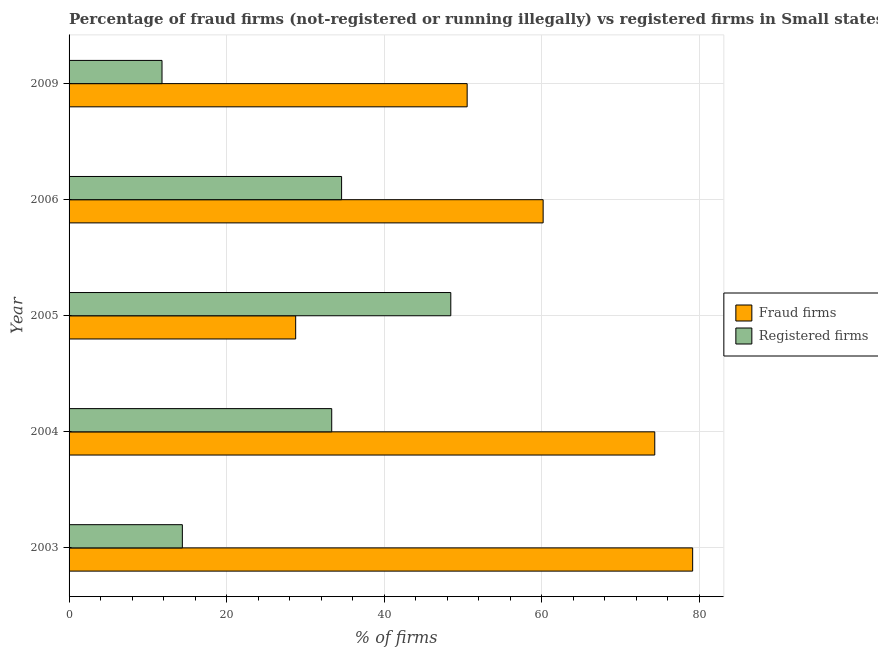How many different coloured bars are there?
Provide a succinct answer. 2. How many groups of bars are there?
Make the answer very short. 5. Are the number of bars per tick equal to the number of legend labels?
Your answer should be very brief. Yes. How many bars are there on the 2nd tick from the bottom?
Ensure brevity in your answer.  2. What is the percentage of fraud firms in 2004?
Offer a very short reply. 74.36. Across all years, what is the maximum percentage of registered firms?
Ensure brevity in your answer.  48.46. Across all years, what is the minimum percentage of fraud firms?
Provide a succinct answer. 28.77. What is the total percentage of registered firms in the graph?
Your answer should be very brief. 142.59. What is the difference between the percentage of fraud firms in 2003 and that in 2006?
Ensure brevity in your answer.  18.98. What is the difference between the percentage of fraud firms in 2006 and the percentage of registered firms in 2004?
Provide a short and direct response. 26.84. What is the average percentage of fraud firms per year?
Ensure brevity in your answer.  58.6. In the year 2005, what is the difference between the percentage of registered firms and percentage of fraud firms?
Provide a succinct answer. 19.69. What is the ratio of the percentage of registered firms in 2005 to that in 2009?
Ensure brevity in your answer.  4.11. Is the percentage of fraud firms in 2005 less than that in 2006?
Your answer should be compact. Yes. Is the difference between the percentage of fraud firms in 2004 and 2009 greater than the difference between the percentage of registered firms in 2004 and 2009?
Offer a terse response. Yes. What is the difference between the highest and the second highest percentage of registered firms?
Make the answer very short. 13.86. What is the difference between the highest and the lowest percentage of registered firms?
Ensure brevity in your answer.  36.66. In how many years, is the percentage of registered firms greater than the average percentage of registered firms taken over all years?
Your answer should be very brief. 3. What does the 1st bar from the top in 2005 represents?
Your response must be concise. Registered firms. What does the 2nd bar from the bottom in 2009 represents?
Your answer should be very brief. Registered firms. How many years are there in the graph?
Give a very brief answer. 5. What is the difference between two consecutive major ticks on the X-axis?
Provide a succinct answer. 20. Are the values on the major ticks of X-axis written in scientific E-notation?
Provide a short and direct response. No. Does the graph contain grids?
Your response must be concise. Yes. Where does the legend appear in the graph?
Your response must be concise. Center right. How are the legend labels stacked?
Keep it short and to the point. Vertical. What is the title of the graph?
Make the answer very short. Percentage of fraud firms (not-registered or running illegally) vs registered firms in Small states. Does "Primary income" appear as one of the legend labels in the graph?
Your answer should be very brief. No. What is the label or title of the X-axis?
Provide a short and direct response. % of firms. What is the label or title of the Y-axis?
Provide a short and direct response. Year. What is the % of firms of Fraud firms in 2003?
Offer a very short reply. 79.17. What is the % of firms in Registered firms in 2003?
Ensure brevity in your answer.  14.38. What is the % of firms of Fraud firms in 2004?
Give a very brief answer. 74.36. What is the % of firms in Registered firms in 2004?
Provide a succinct answer. 33.35. What is the % of firms of Fraud firms in 2005?
Ensure brevity in your answer.  28.77. What is the % of firms of Registered firms in 2005?
Keep it short and to the point. 48.46. What is the % of firms in Fraud firms in 2006?
Offer a terse response. 60.19. What is the % of firms in Registered firms in 2006?
Provide a succinct answer. 34.6. What is the % of firms in Fraud firms in 2009?
Keep it short and to the point. 50.54. What is the % of firms in Registered firms in 2009?
Give a very brief answer. 11.8. Across all years, what is the maximum % of firms of Fraud firms?
Offer a terse response. 79.17. Across all years, what is the maximum % of firms of Registered firms?
Offer a very short reply. 48.46. Across all years, what is the minimum % of firms in Fraud firms?
Your answer should be very brief. 28.77. Across all years, what is the minimum % of firms of Registered firms?
Your answer should be very brief. 11.8. What is the total % of firms in Fraud firms in the graph?
Provide a short and direct response. 293.03. What is the total % of firms of Registered firms in the graph?
Give a very brief answer. 142.59. What is the difference between the % of firms in Fraud firms in 2003 and that in 2004?
Provide a short and direct response. 4.81. What is the difference between the % of firms in Registered firms in 2003 and that in 2004?
Your response must be concise. -18.96. What is the difference between the % of firms of Fraud firms in 2003 and that in 2005?
Offer a very short reply. 50.4. What is the difference between the % of firms in Registered firms in 2003 and that in 2005?
Your answer should be compact. -34.08. What is the difference between the % of firms in Fraud firms in 2003 and that in 2006?
Your answer should be very brief. 18.98. What is the difference between the % of firms of Registered firms in 2003 and that in 2006?
Offer a terse response. -20.22. What is the difference between the % of firms in Fraud firms in 2003 and that in 2009?
Provide a short and direct response. 28.63. What is the difference between the % of firms in Registered firms in 2003 and that in 2009?
Provide a short and direct response. 2.58. What is the difference between the % of firms in Fraud firms in 2004 and that in 2005?
Make the answer very short. 45.59. What is the difference between the % of firms in Registered firms in 2004 and that in 2005?
Your answer should be very brief. -15.12. What is the difference between the % of firms in Fraud firms in 2004 and that in 2006?
Provide a short and direct response. 14.17. What is the difference between the % of firms in Registered firms in 2004 and that in 2006?
Give a very brief answer. -1.25. What is the difference between the % of firms of Fraud firms in 2004 and that in 2009?
Provide a short and direct response. 23.82. What is the difference between the % of firms in Registered firms in 2004 and that in 2009?
Your answer should be very brief. 21.55. What is the difference between the % of firms in Fraud firms in 2005 and that in 2006?
Ensure brevity in your answer.  -31.42. What is the difference between the % of firms of Registered firms in 2005 and that in 2006?
Provide a short and direct response. 13.86. What is the difference between the % of firms in Fraud firms in 2005 and that in 2009?
Your answer should be compact. -21.77. What is the difference between the % of firms of Registered firms in 2005 and that in 2009?
Give a very brief answer. 36.66. What is the difference between the % of firms of Fraud firms in 2006 and that in 2009?
Your response must be concise. 9.65. What is the difference between the % of firms of Registered firms in 2006 and that in 2009?
Keep it short and to the point. 22.8. What is the difference between the % of firms in Fraud firms in 2003 and the % of firms in Registered firms in 2004?
Offer a very short reply. 45.82. What is the difference between the % of firms in Fraud firms in 2003 and the % of firms in Registered firms in 2005?
Offer a very short reply. 30.71. What is the difference between the % of firms in Fraud firms in 2003 and the % of firms in Registered firms in 2006?
Provide a short and direct response. 44.57. What is the difference between the % of firms of Fraud firms in 2003 and the % of firms of Registered firms in 2009?
Offer a terse response. 67.37. What is the difference between the % of firms of Fraud firms in 2004 and the % of firms of Registered firms in 2005?
Give a very brief answer. 25.9. What is the difference between the % of firms of Fraud firms in 2004 and the % of firms of Registered firms in 2006?
Give a very brief answer. 39.76. What is the difference between the % of firms of Fraud firms in 2004 and the % of firms of Registered firms in 2009?
Ensure brevity in your answer.  62.56. What is the difference between the % of firms in Fraud firms in 2005 and the % of firms in Registered firms in 2006?
Keep it short and to the point. -5.83. What is the difference between the % of firms of Fraud firms in 2005 and the % of firms of Registered firms in 2009?
Your answer should be compact. 16.97. What is the difference between the % of firms in Fraud firms in 2006 and the % of firms in Registered firms in 2009?
Offer a very short reply. 48.39. What is the average % of firms in Fraud firms per year?
Keep it short and to the point. 58.61. What is the average % of firms in Registered firms per year?
Offer a very short reply. 28.52. In the year 2003, what is the difference between the % of firms of Fraud firms and % of firms of Registered firms?
Your answer should be compact. 64.79. In the year 2004, what is the difference between the % of firms in Fraud firms and % of firms in Registered firms?
Provide a succinct answer. 41.01. In the year 2005, what is the difference between the % of firms of Fraud firms and % of firms of Registered firms?
Your response must be concise. -19.69. In the year 2006, what is the difference between the % of firms of Fraud firms and % of firms of Registered firms?
Provide a succinct answer. 25.59. In the year 2009, what is the difference between the % of firms in Fraud firms and % of firms in Registered firms?
Offer a very short reply. 38.74. What is the ratio of the % of firms in Fraud firms in 2003 to that in 2004?
Your answer should be compact. 1.06. What is the ratio of the % of firms in Registered firms in 2003 to that in 2004?
Provide a short and direct response. 0.43. What is the ratio of the % of firms of Fraud firms in 2003 to that in 2005?
Your answer should be very brief. 2.75. What is the ratio of the % of firms of Registered firms in 2003 to that in 2005?
Make the answer very short. 0.3. What is the ratio of the % of firms of Fraud firms in 2003 to that in 2006?
Provide a succinct answer. 1.32. What is the ratio of the % of firms in Registered firms in 2003 to that in 2006?
Keep it short and to the point. 0.42. What is the ratio of the % of firms in Fraud firms in 2003 to that in 2009?
Offer a terse response. 1.57. What is the ratio of the % of firms in Registered firms in 2003 to that in 2009?
Offer a terse response. 1.22. What is the ratio of the % of firms in Fraud firms in 2004 to that in 2005?
Provide a succinct answer. 2.58. What is the ratio of the % of firms of Registered firms in 2004 to that in 2005?
Your response must be concise. 0.69. What is the ratio of the % of firms of Fraud firms in 2004 to that in 2006?
Ensure brevity in your answer.  1.24. What is the ratio of the % of firms in Registered firms in 2004 to that in 2006?
Offer a terse response. 0.96. What is the ratio of the % of firms in Fraud firms in 2004 to that in 2009?
Provide a short and direct response. 1.47. What is the ratio of the % of firms in Registered firms in 2004 to that in 2009?
Ensure brevity in your answer.  2.83. What is the ratio of the % of firms in Fraud firms in 2005 to that in 2006?
Offer a terse response. 0.48. What is the ratio of the % of firms in Registered firms in 2005 to that in 2006?
Offer a terse response. 1.4. What is the ratio of the % of firms in Fraud firms in 2005 to that in 2009?
Give a very brief answer. 0.57. What is the ratio of the % of firms in Registered firms in 2005 to that in 2009?
Your response must be concise. 4.11. What is the ratio of the % of firms in Fraud firms in 2006 to that in 2009?
Give a very brief answer. 1.19. What is the ratio of the % of firms in Registered firms in 2006 to that in 2009?
Give a very brief answer. 2.93. What is the difference between the highest and the second highest % of firms of Fraud firms?
Offer a terse response. 4.81. What is the difference between the highest and the second highest % of firms of Registered firms?
Ensure brevity in your answer.  13.86. What is the difference between the highest and the lowest % of firms of Fraud firms?
Your answer should be very brief. 50.4. What is the difference between the highest and the lowest % of firms of Registered firms?
Make the answer very short. 36.66. 